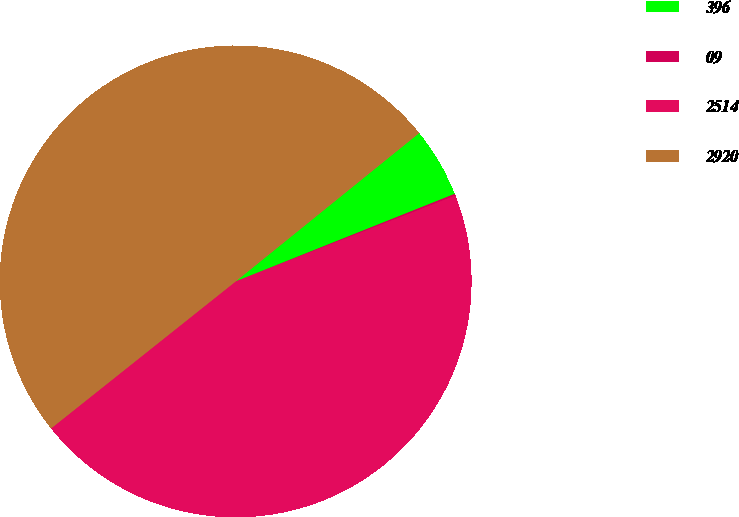<chart> <loc_0><loc_0><loc_500><loc_500><pie_chart><fcel>396<fcel>09<fcel>2514<fcel>2920<nl><fcel>4.77%<fcel>0.12%<fcel>45.23%<fcel>49.88%<nl></chart> 